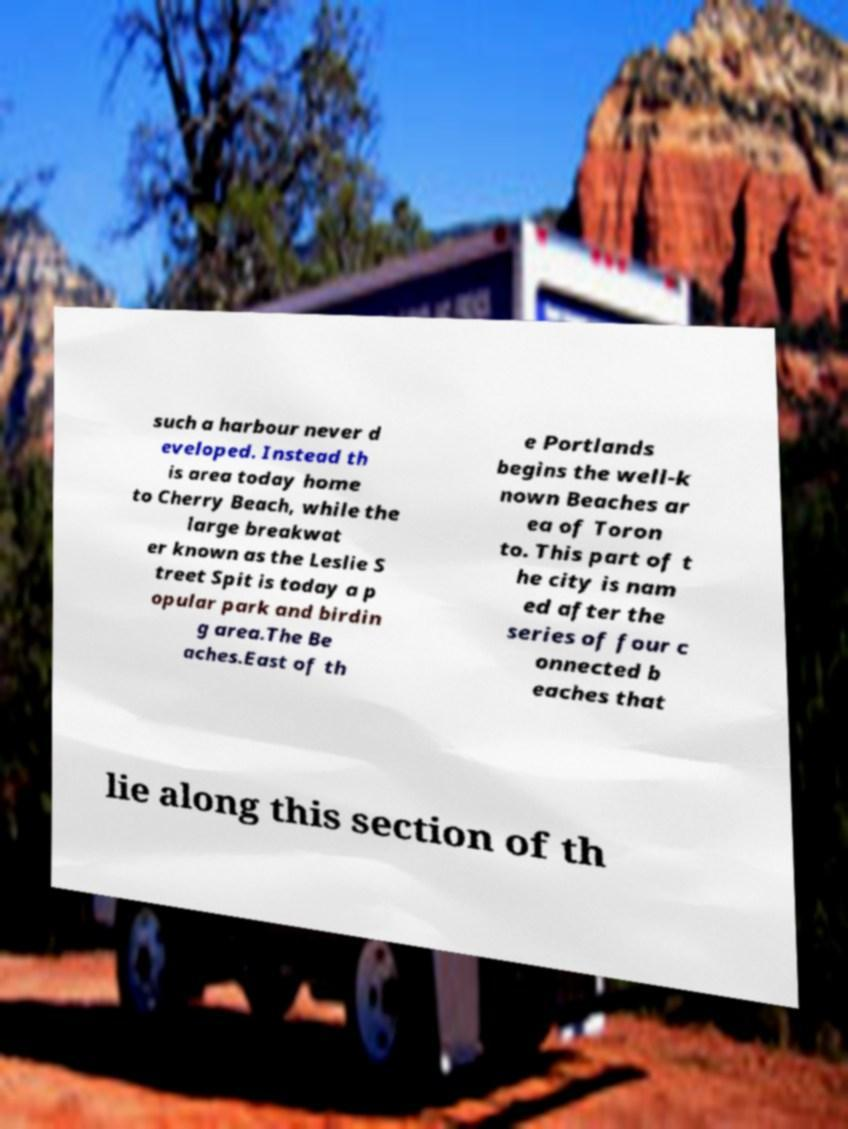Could you extract and type out the text from this image? such a harbour never d eveloped. Instead th is area today home to Cherry Beach, while the large breakwat er known as the Leslie S treet Spit is today a p opular park and birdin g area.The Be aches.East of th e Portlands begins the well-k nown Beaches ar ea of Toron to. This part of t he city is nam ed after the series of four c onnected b eaches that lie along this section of th 